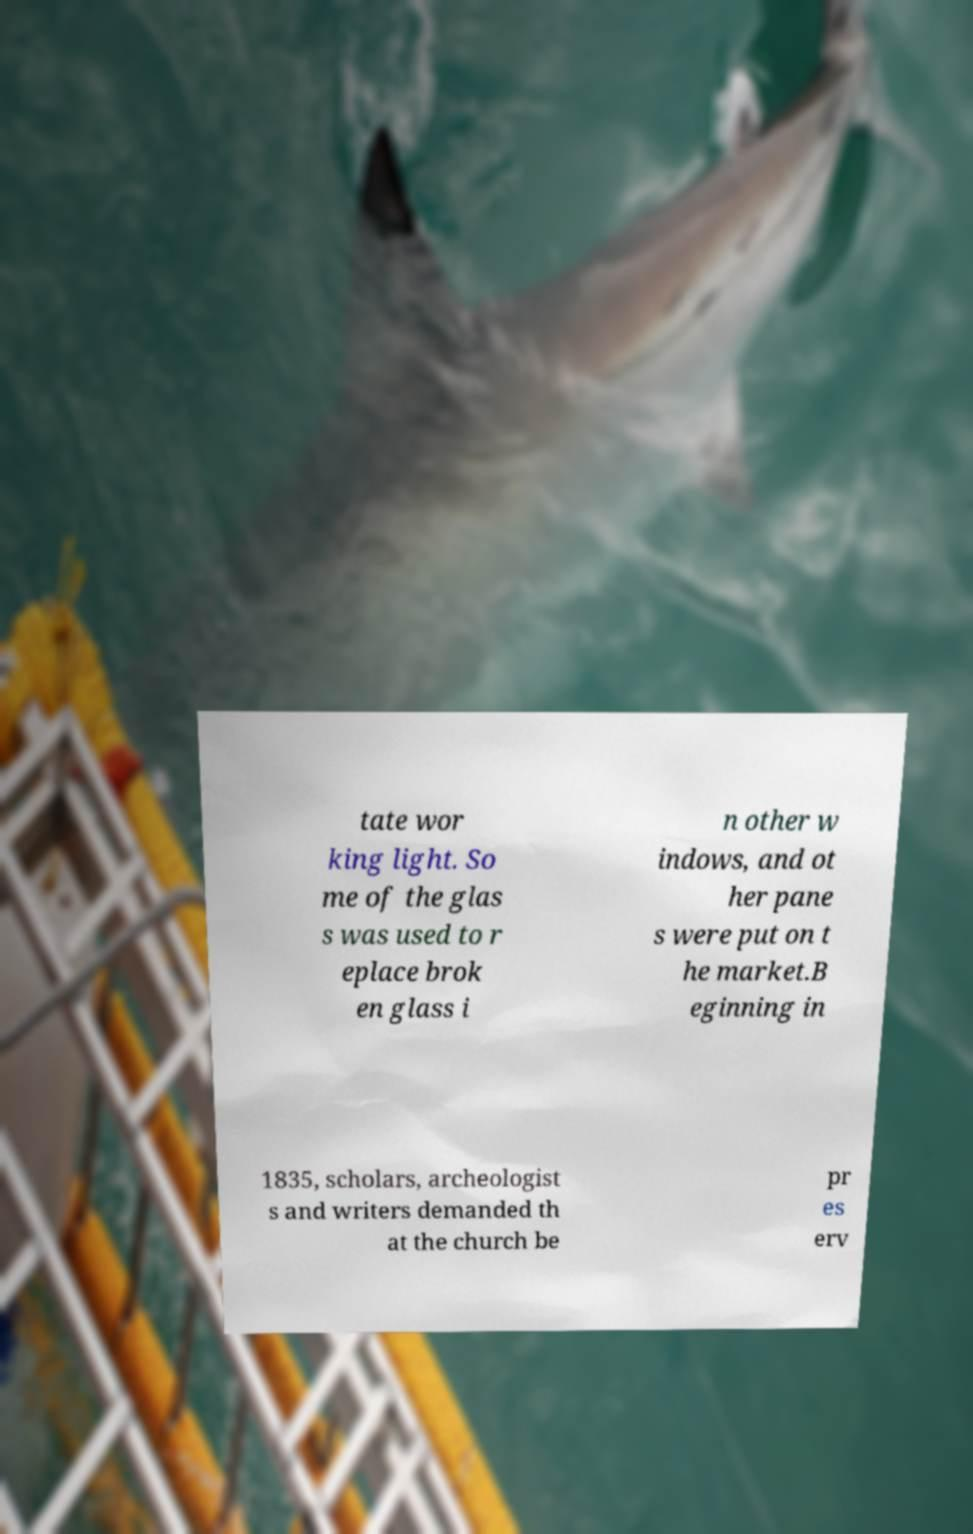What messages or text are displayed in this image? I need them in a readable, typed format. tate wor king light. So me of the glas s was used to r eplace brok en glass i n other w indows, and ot her pane s were put on t he market.B eginning in 1835, scholars, archeologist s and writers demanded th at the church be pr es erv 